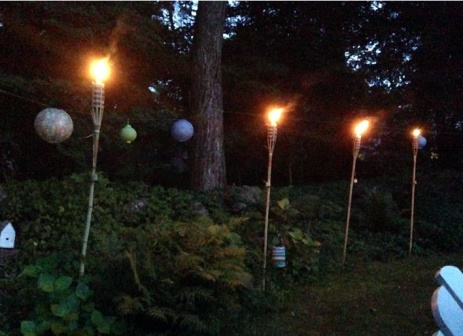Can you describe the types of plants seen in the garden? The garden features a variety of plants creating a lush and vibrant scene. Among these, ferns are prominently visible, recognized for their intricate fronds that add texture and depth. Hostas are also notable, their broad, variegated leaves providing a striking contrast against the darker foliage. The mix of greenery suggests a thoughtfully curated garden, designed to thrive in the dim light of the torches and lanterns. 